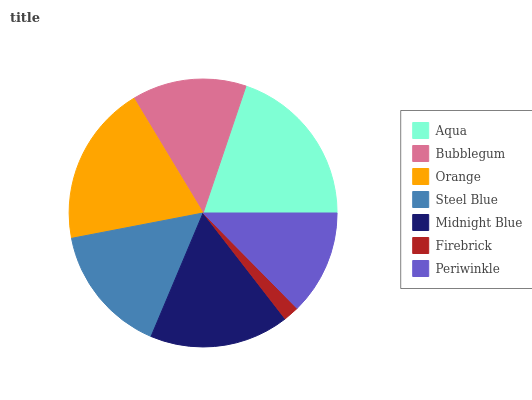Is Firebrick the minimum?
Answer yes or no. Yes. Is Aqua the maximum?
Answer yes or no. Yes. Is Bubblegum the minimum?
Answer yes or no. No. Is Bubblegum the maximum?
Answer yes or no. No. Is Aqua greater than Bubblegum?
Answer yes or no. Yes. Is Bubblegum less than Aqua?
Answer yes or no. Yes. Is Bubblegum greater than Aqua?
Answer yes or no. No. Is Aqua less than Bubblegum?
Answer yes or no. No. Is Steel Blue the high median?
Answer yes or no. Yes. Is Steel Blue the low median?
Answer yes or no. Yes. Is Midnight Blue the high median?
Answer yes or no. No. Is Periwinkle the low median?
Answer yes or no. No. 